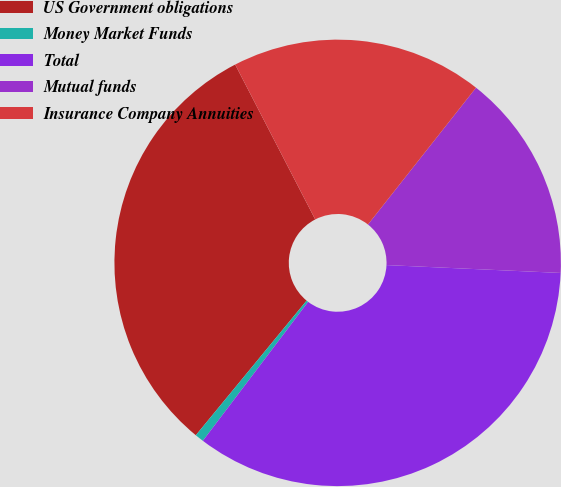Convert chart to OTSL. <chart><loc_0><loc_0><loc_500><loc_500><pie_chart><fcel>US Government obligations<fcel>Money Market Funds<fcel>Total<fcel>Mutual funds<fcel>Insurance Company Annuities<nl><fcel>31.45%<fcel>0.64%<fcel>34.6%<fcel>15.08%<fcel>18.23%<nl></chart> 